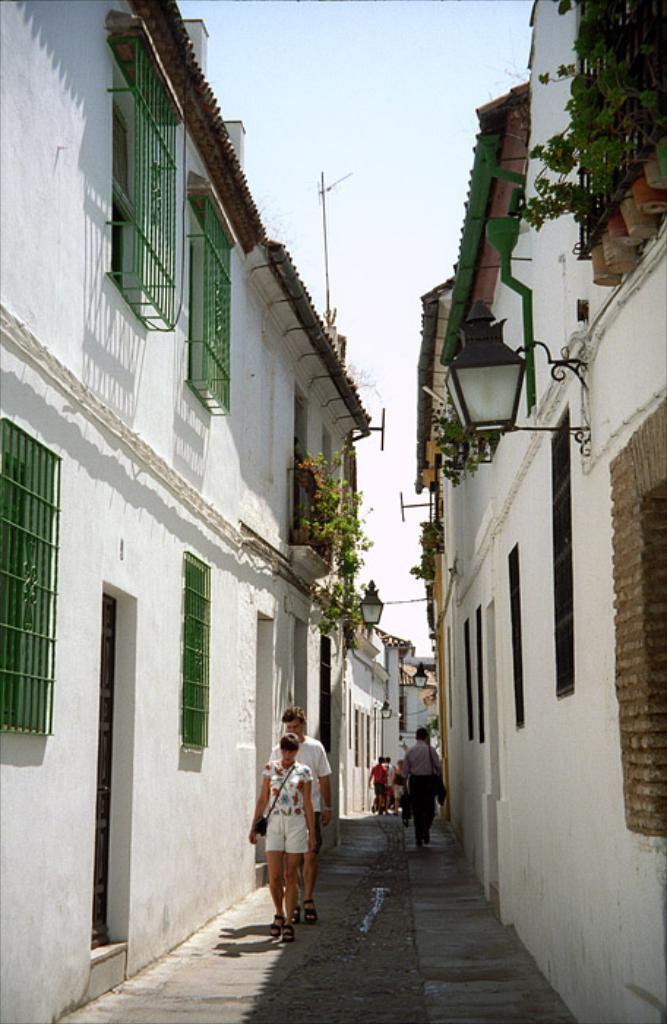Describe this image in one or two sentences. Here we can see few persons. There are buildings, windows, plants, lights, and poles. In the background there is sky. 